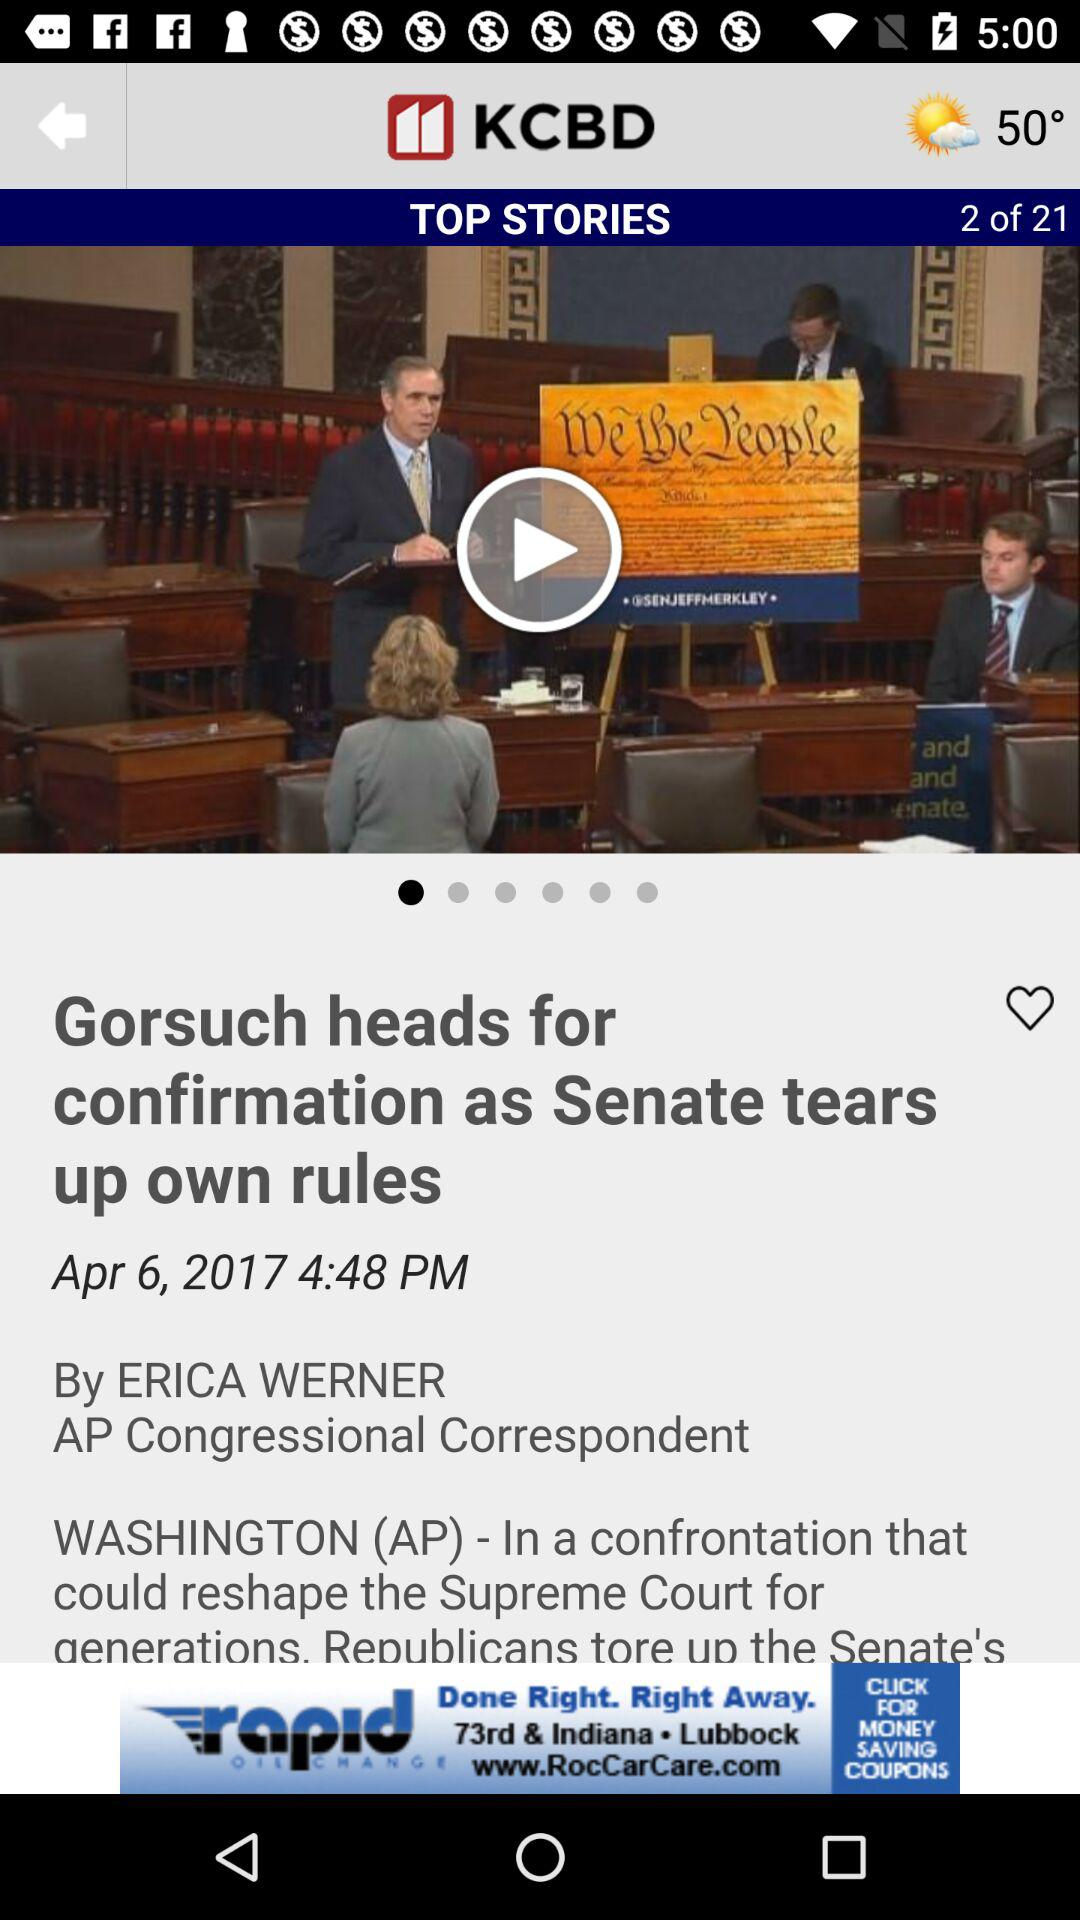What is the total number of "TOP STORIES"? The total number is 21. 